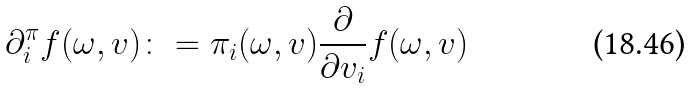Convert formula to latex. <formula><loc_0><loc_0><loc_500><loc_500>\partial _ { i } ^ { \pi } f ( \omega , v ) \colon = \pi _ { i } ( \omega , v ) \frac { \partial } { \partial v _ { i } } f ( \omega , v )</formula> 